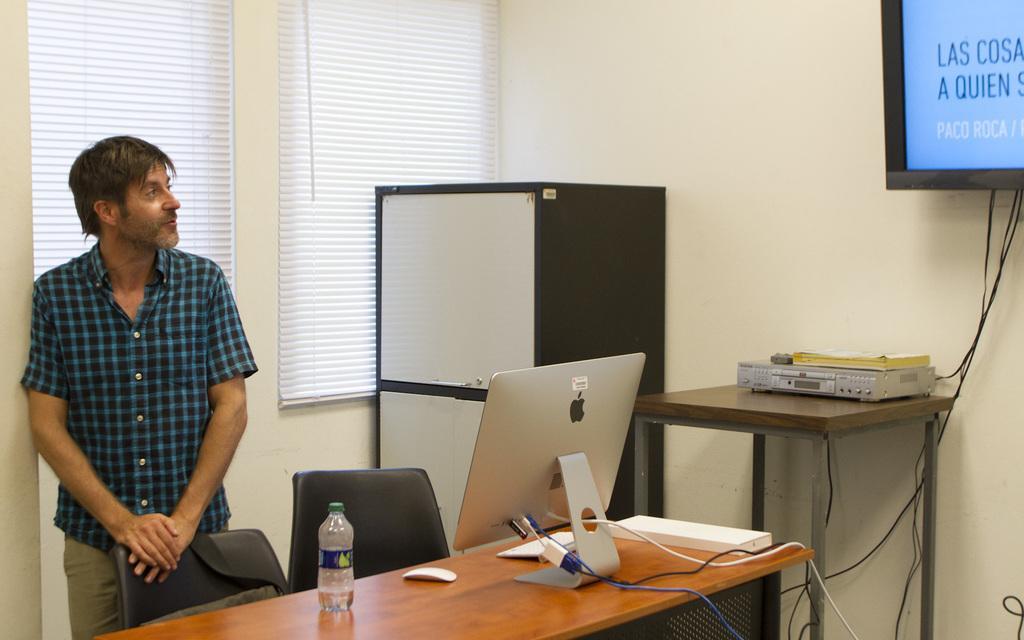Please provide a concise description of this image. A man is standing on a left side. In this there are chairs, tables, cupboard. On the table there is a computer, mouse, and keyboard also a bottle. Also in another table there is a receiver. On the wall there is a screen, curtains. 